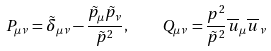Convert formula to latex. <formula><loc_0><loc_0><loc_500><loc_500>P _ { \mu \nu } = \tilde { \delta } _ { \mu \nu } - \frac { \tilde { p } _ { \mu } \tilde { p } _ { \nu } } { \tilde { p } ^ { 2 } } , \quad Q _ { \mu \nu } = \frac { p ^ { 2 } } { \tilde { p } ^ { 2 } } \overline { u } _ { \mu } \overline { u } _ { \nu }</formula> 